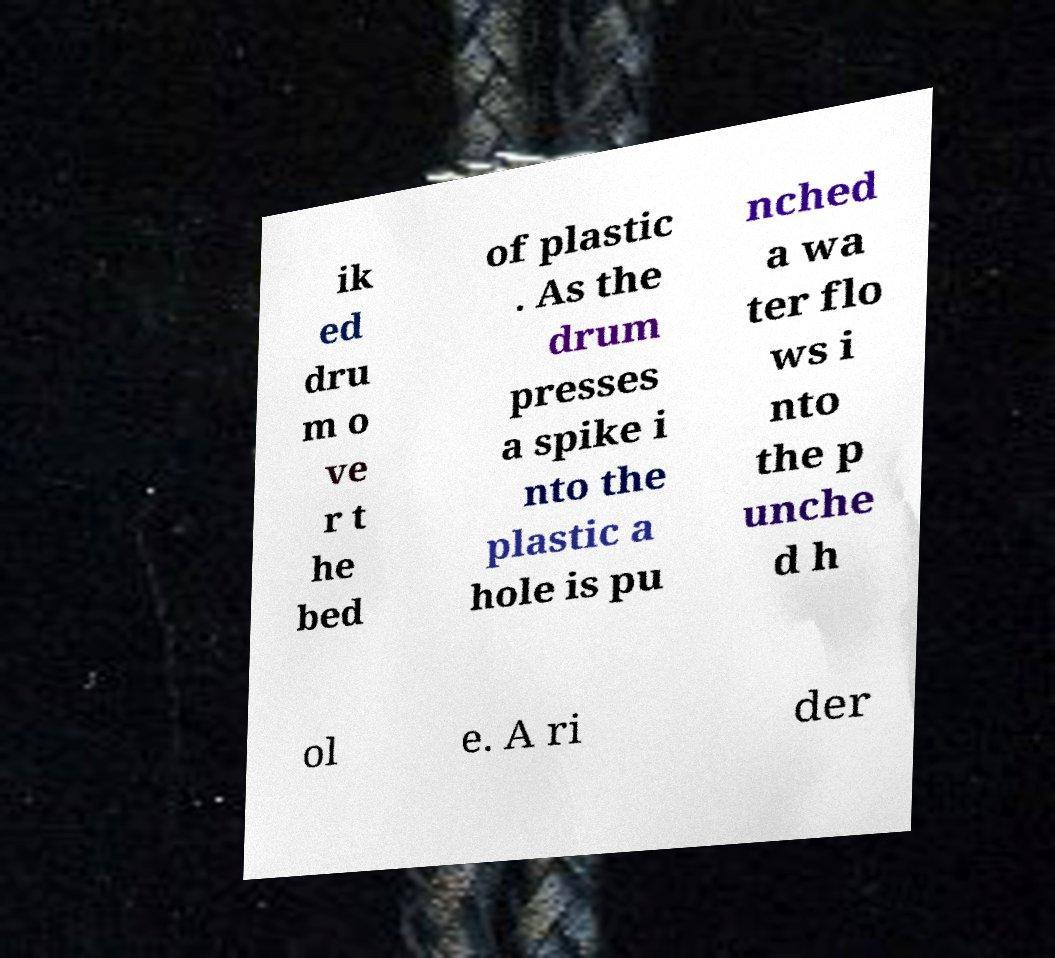What messages or text are displayed in this image? I need them in a readable, typed format. ik ed dru m o ve r t he bed of plastic . As the drum presses a spike i nto the plastic a hole is pu nched a wa ter flo ws i nto the p unche d h ol e. A ri der 